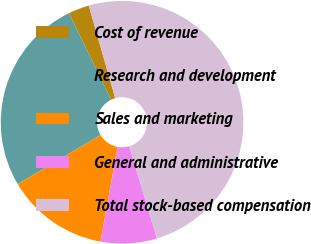<chart> <loc_0><loc_0><loc_500><loc_500><pie_chart><fcel>Cost of revenue<fcel>Research and development<fcel>Sales and marketing<fcel>General and administrative<fcel>Total stock-based compensation<nl><fcel>2.78%<fcel>26.31%<fcel>13.64%<fcel>7.48%<fcel>49.79%<nl></chart> 